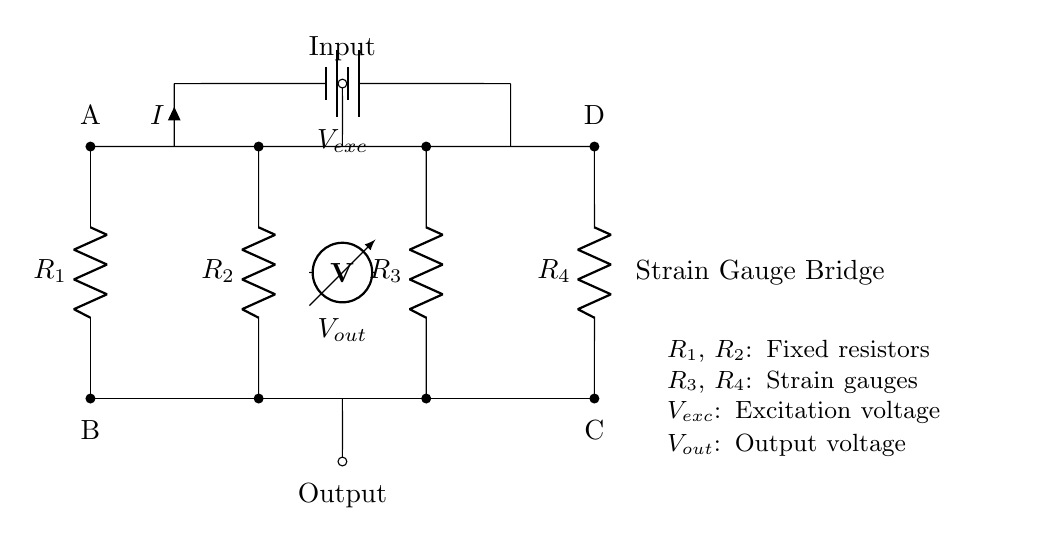What are the components labeled in this circuit? The circuit has four resistors labeled R1, R2, R3, and R4. Additionally, it includes a battery for excitation voltage and a voltmeter for output voltage.
Answer: R1, R2, R3, R4, Vexc, Vout What is the purpose of the strain gauges in this bridge circuit? Strain gauges (R3 and R4) are used to measure mechanical stress by changing their resistance when subjected to strain, thus affecting the output voltage.
Answer: Measure mechanical stress What is the excitation voltage in this circuit? The excitation voltage, denoted as Vexc, is the voltage supplied to the circuit to balance the bridge and enable the measurement of output voltage.
Answer: Vexc How is the output voltage (Vout) taken from this circuit? The output voltage (Vout) is measured across the midpoints of the two branches of the bridge, where the voltmeter is connected, indicating the difference in voltage due to changes in resistance from the strain gauges.
Answer: Across the midpoints What happens to the output voltage (Vout) if one of the strain gauges is deformed? If one of the strain gauges is deformed, its resistance changes, which will create an imbalance in the bridge circuit, resulting in a measurable change in output voltage (Vout).
Answer: Changes due to imbalance What type of circuit configuration is shown in this diagram? This is a Wheatstone bridge configuration, commonly used for measuring unknown resistances or changes in resistances in strain gauges.
Answer: Wheatstone bridge What is the expected effect on Vout when R3 increases and R4 decreases equally due to an applied strain? If R3 increases and R4 decreases equally, the output voltage (Vout) will change because the difference in resistance between the two paths will alter the voltage measured by the voltmeter. The Vout will increase or decrease based on the direction of the strain.
Answer: Expect a change in Vout 